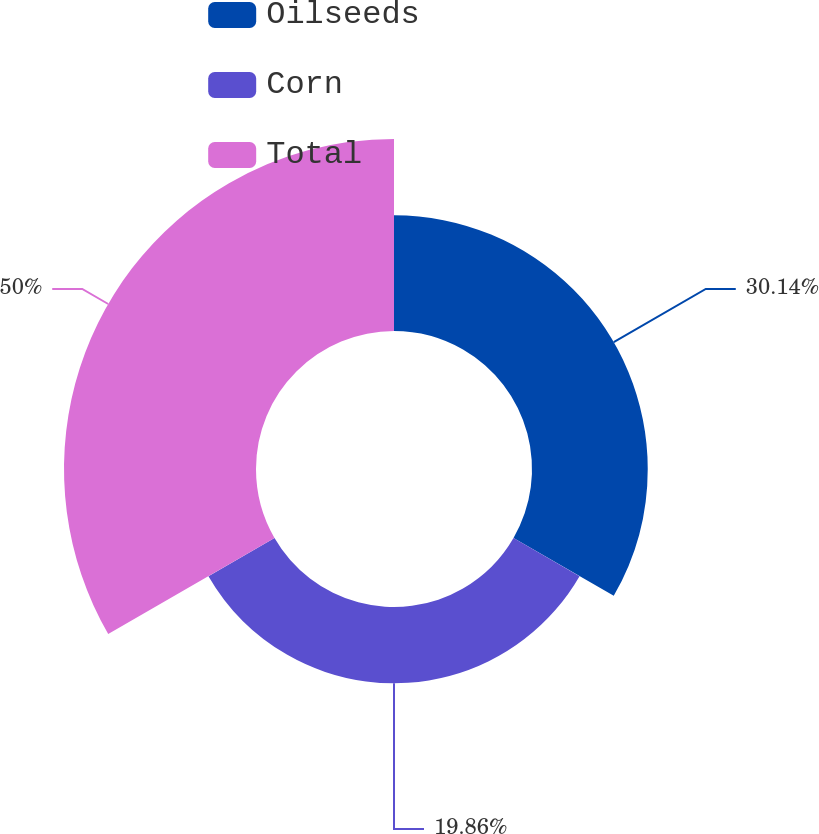Convert chart. <chart><loc_0><loc_0><loc_500><loc_500><pie_chart><fcel>Oilseeds<fcel>Corn<fcel>Total<nl><fcel>30.14%<fcel>19.86%<fcel>50.0%<nl></chart> 